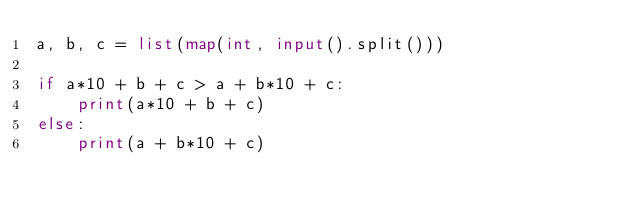Convert code to text. <code><loc_0><loc_0><loc_500><loc_500><_Python_>a, b, c = list(map(int, input().split()))

if a*10 + b + c > a + b*10 + c:
    print(a*10 + b + c)
else:
    print(a + b*10 + c)
</code> 